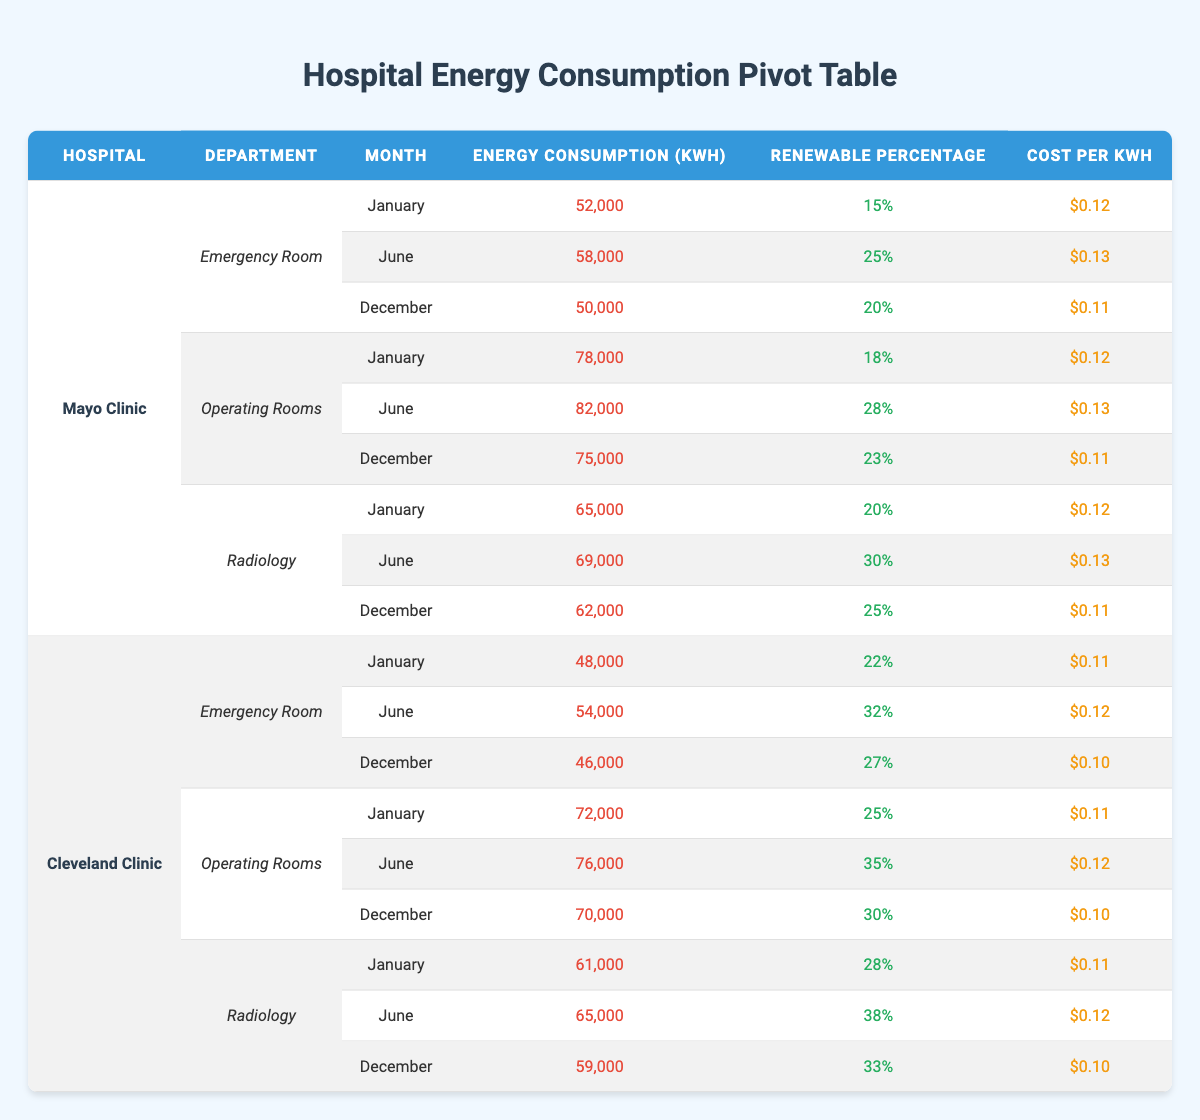What was the energy consumption in the Operating Rooms of the Mayo Clinic in December? The table shows that for the Operating Rooms at the Mayo Clinic in December, the energy consumption was 75,000 kWh.
Answer: 75,000 kWh Which hospital department had the highest renewable energy percentage in January? In January, the Cleveland Clinic's Radiology department had the highest renewable energy percentage at 28%.
Answer: 28% What is the total energy consumption for the Emergency Room at the Cleveland Clinic over the three months? For the Emergency Room at the Cleveland Clinic, the energy consumption was 48,000 kWh in January, 54,000 kWh in June, and 46,000 kWh in December. Adding them: (48,000 + 54,000 + 46,000) = 148,000 kWh.
Answer: 148,000 kWh Did the Operating Rooms in the Mayo Clinic consume more energy in June than in January? In June, the Operating Rooms consumed 82,000 kWh, which is greater than the 78,000 kWh consumed in January. Therefore, yes, they consumed more energy in June than in January.
Answer: Yes What was the average cost per kWh for the Radiology department at Mayo Clinic across the three months? The costs per kWh for the Radiology department were $0.12 in January, $0.13 in June, and $0.11 in December. Calculating the average: (0.12 + 0.13 + 0.11)/3 = 0.12.
Answer: $0.12 Which department in the Cleveland Clinic had the lowest energy consumption in December? In December, the energy consumption values for the Cleveland Clinic departments are 46,000 kWh for the Emergency Room, 70,000 kWh for Operating Rooms, and 59,000 kWh for Radiology. The Emergency Room had the lowest at 46,000 kWh.
Answer: Emergency Room How much more did the Operating Rooms at Cleveland Clinic consume in June compared to December? In June, the Operating Rooms consumed 76,000 kWh, and in December they consumed 70,000 kWh. The difference is (76,000 - 70,000) = 6,000 kWh.
Answer: 6,000 kWh Is it true that the Renewable Percentage for Emergency Rooms at Mayo Clinic increased from January to June? In January, the Renewable Percentage was 15%, which increased to 25% in June for the Emergency Room of Mayo Clinic. Therefore, the statement is true.
Answer: True 